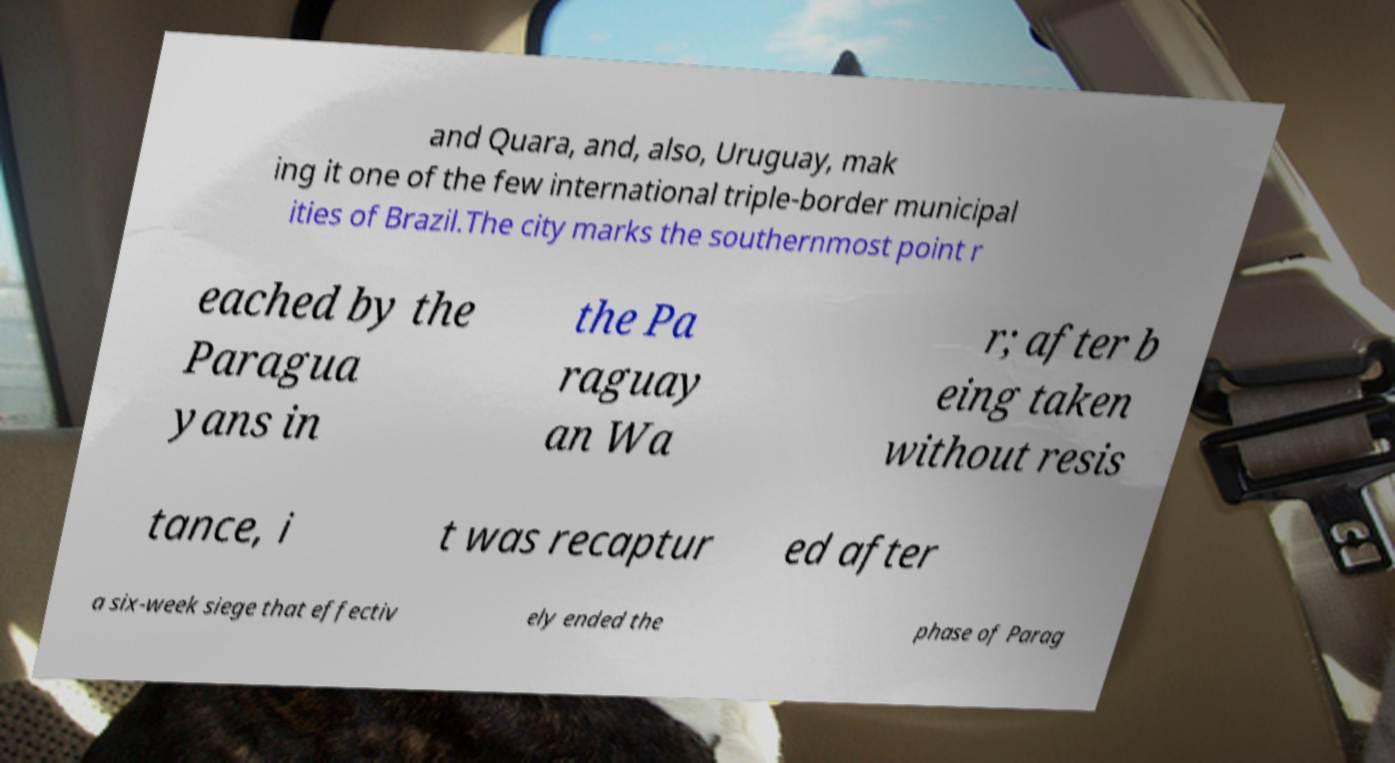Please read and relay the text visible in this image. What does it say? and Quara, and, also, Uruguay, mak ing it one of the few international triple-border municipal ities of Brazil.The city marks the southernmost point r eached by the Paragua yans in the Pa raguay an Wa r; after b eing taken without resis tance, i t was recaptur ed after a six-week siege that effectiv ely ended the phase of Parag 